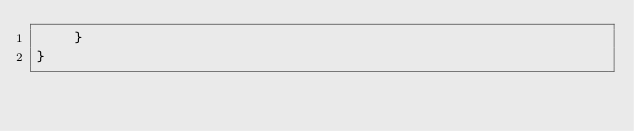Convert code to text. <code><loc_0><loc_0><loc_500><loc_500><_Java_>    }
}
</code> 